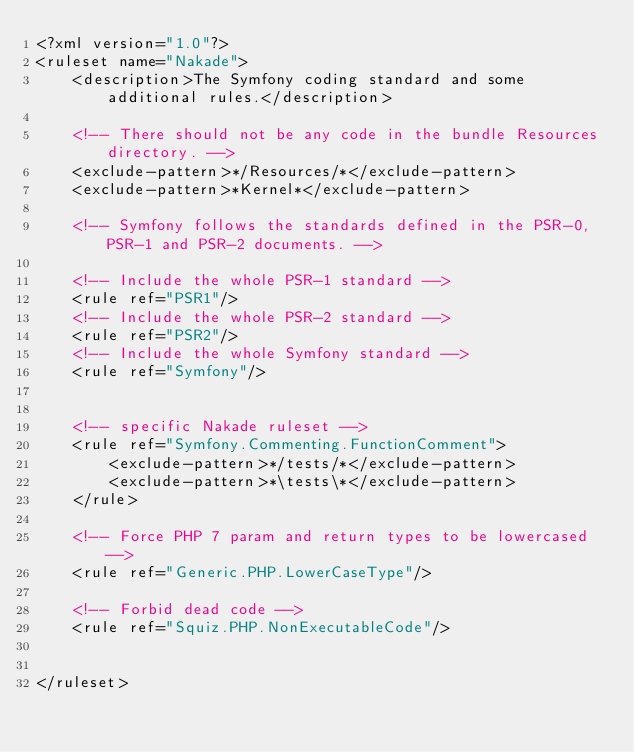<code> <loc_0><loc_0><loc_500><loc_500><_XML_><?xml version="1.0"?>
<ruleset name="Nakade">
    <description>The Symfony coding standard and some additional rules.</description>

    <!-- There should not be any code in the bundle Resources directory. -->
    <exclude-pattern>*/Resources/*</exclude-pattern>
    <exclude-pattern>*Kernel*</exclude-pattern>

    <!-- Symfony follows the standards defined in the PSR-0, PSR-1 and PSR-2 documents. -->

    <!-- Include the whole PSR-1 standard -->
    <rule ref="PSR1"/>
    <!-- Include the whole PSR-2 standard -->
    <rule ref="PSR2"/>
    <!-- Include the whole Symfony standard -->
    <rule ref="Symfony"/>


    <!-- specific Nakade ruleset -->
    <rule ref="Symfony.Commenting.FunctionComment">
        <exclude-pattern>*/tests/*</exclude-pattern>
        <exclude-pattern>*\tests\*</exclude-pattern>
    </rule>

    <!-- Force PHP 7 param and return types to be lowercased -->
    <rule ref="Generic.PHP.LowerCaseType"/>

    <!-- Forbid dead code -->
    <rule ref="Squiz.PHP.NonExecutableCode"/>


</ruleset>
</code> 